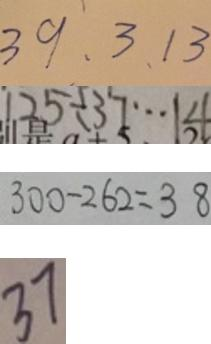<formula> <loc_0><loc_0><loc_500><loc_500>3 9 、 3 、 1 3 
 1 2 5 \div 3 7 \cdots 1 4 
 3 0 0 - 2 6 2 = 3 8 
 3 7</formula> 